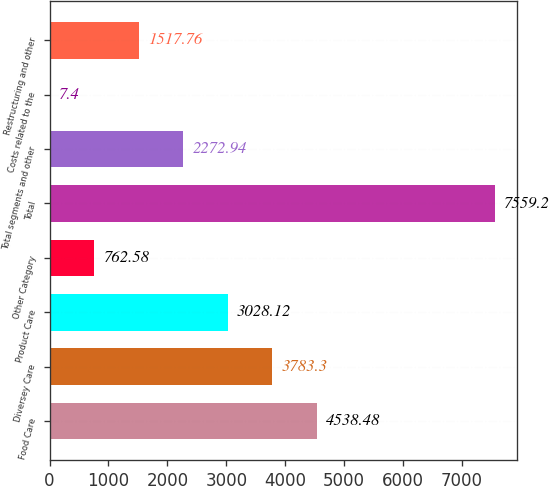Convert chart. <chart><loc_0><loc_0><loc_500><loc_500><bar_chart><fcel>Food Care<fcel>Diversey Care<fcel>Product Care<fcel>Other Category<fcel>Total<fcel>Total segments and other<fcel>Costs related to the<fcel>Restructuring and other<nl><fcel>4538.48<fcel>3783.3<fcel>3028.12<fcel>762.58<fcel>7559.2<fcel>2272.94<fcel>7.4<fcel>1517.76<nl></chart> 